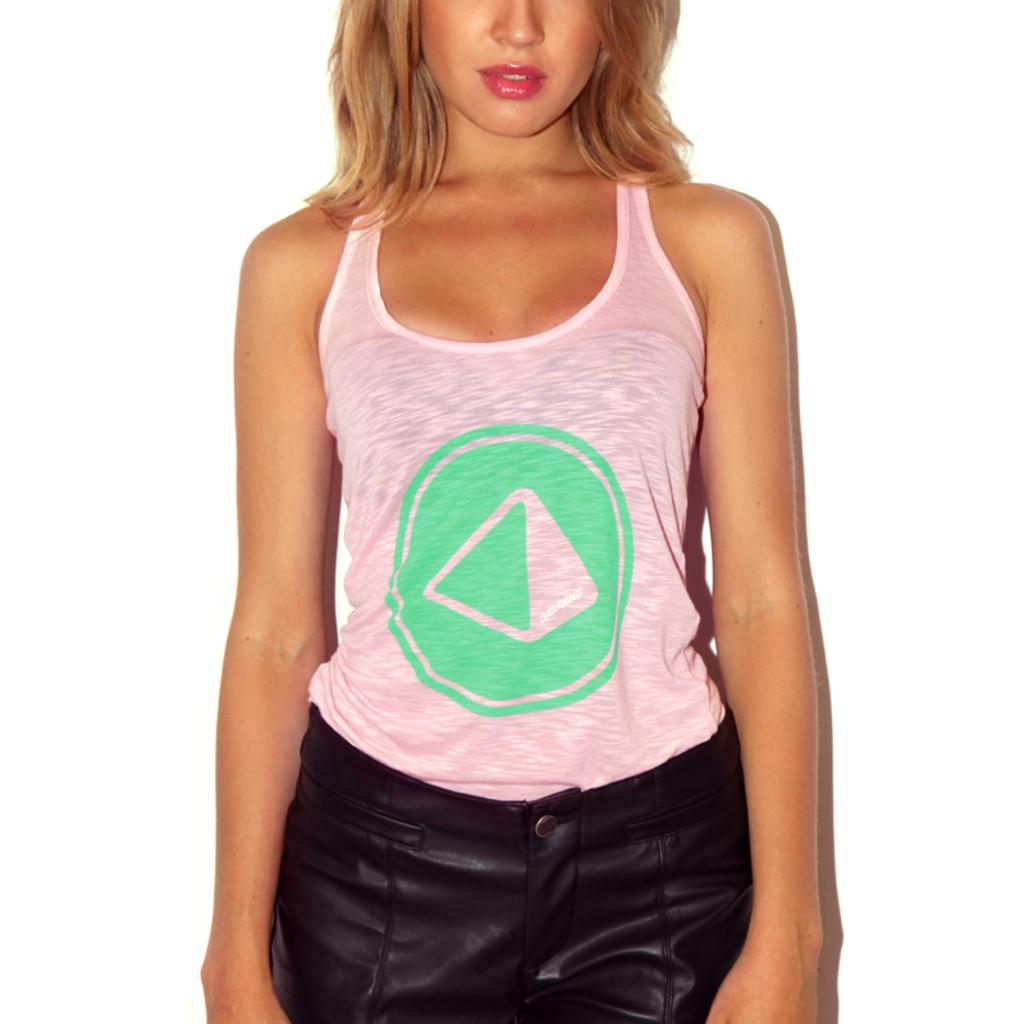What is the main subject of the image? There is a person standing in the image. Can you describe the person's clothing? The person is wearing a dress with black, green, and pink colors. What is the color of the background in the image? The background of the image is white. How many goldfish are swimming in the dress of the person in the image? There are no goldfish present in the image; the person is wearing a dress with black, green, and pink colors. 